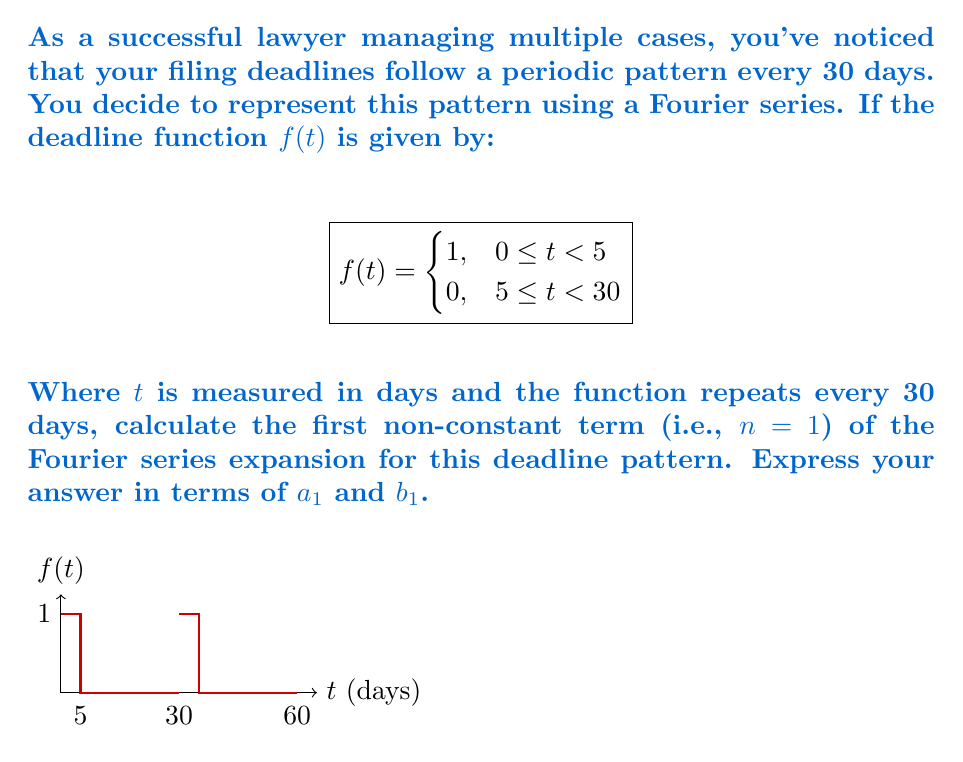Can you answer this question? To find the first non-constant term of the Fourier series, we need to calculate $a_1$ and $b_1$. The general formulas for these coefficients are:

$$a_n = \frac{2}{T}\int_0^T f(t)\cos(\frac{2\pi nt}{T})dt$$
$$b_n = \frac{2}{T}\int_0^T f(t)\sin(\frac{2\pi nt}{T})dt$$

Where $T$ is the period, which in this case is 30 days.

For $n=1$:

1) Calculate $a_1$:
   $$a_1 = \frac{2}{30}\int_0^5 1\cos(\frac{2\pi t}{30})dt + \frac{2}{30}\int_5^{30} 0\cos(\frac{2\pi t}{30})dt$$
   $$= \frac{2}{30}[\frac{30}{2\pi}\sin(\frac{2\pi t}{30})]_0^5$$
   $$= \frac{1}{\pi}[\sin(\frac{\pi}{3}) - \sin(0)]$$
   $$= \frac{\sqrt{3}}{2\pi}$$

2) Calculate $b_1$:
   $$b_1 = \frac{2}{30}\int_0^5 1\sin(\frac{2\pi t}{30})dt + \frac{2}{30}\int_5^{30} 0\sin(\frac{2\pi t}{30})dt$$
   $$= \frac{2}{30}[-\frac{30}{2\pi}\cos(\frac{2\pi t}{30})]_0^5$$
   $$= -\frac{1}{\pi}[\cos(\frac{\pi}{3}) - \cos(0)]$$
   $$= \frac{1}{2\pi}$$

The first non-constant term of the Fourier series is thus:

$$a_1\cos(\frac{2\pi t}{30}) + b_1\sin(\frac{2\pi t}{30})$$
Answer: $\frac{\sqrt{3}}{2\pi}\cos(\frac{2\pi t}{30}) + \frac{1}{2\pi}\sin(\frac{2\pi t}{30})$ 